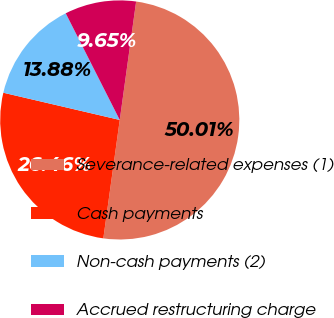<chart> <loc_0><loc_0><loc_500><loc_500><pie_chart><fcel>Severance-related expenses (1)<fcel>Cash payments<fcel>Non-cash payments (2)<fcel>Accrued restructuring charge<nl><fcel>50.0%<fcel>26.46%<fcel>13.88%<fcel>9.65%<nl></chart> 